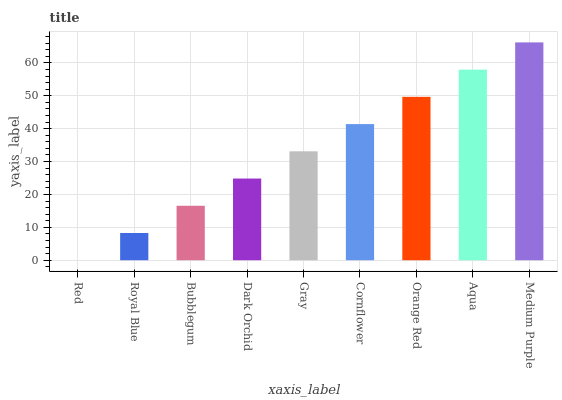Is Royal Blue the minimum?
Answer yes or no. No. Is Royal Blue the maximum?
Answer yes or no. No. Is Royal Blue greater than Red?
Answer yes or no. Yes. Is Red less than Royal Blue?
Answer yes or no. Yes. Is Red greater than Royal Blue?
Answer yes or no. No. Is Royal Blue less than Red?
Answer yes or no. No. Is Gray the high median?
Answer yes or no. Yes. Is Gray the low median?
Answer yes or no. Yes. Is Red the high median?
Answer yes or no. No. Is Dark Orchid the low median?
Answer yes or no. No. 